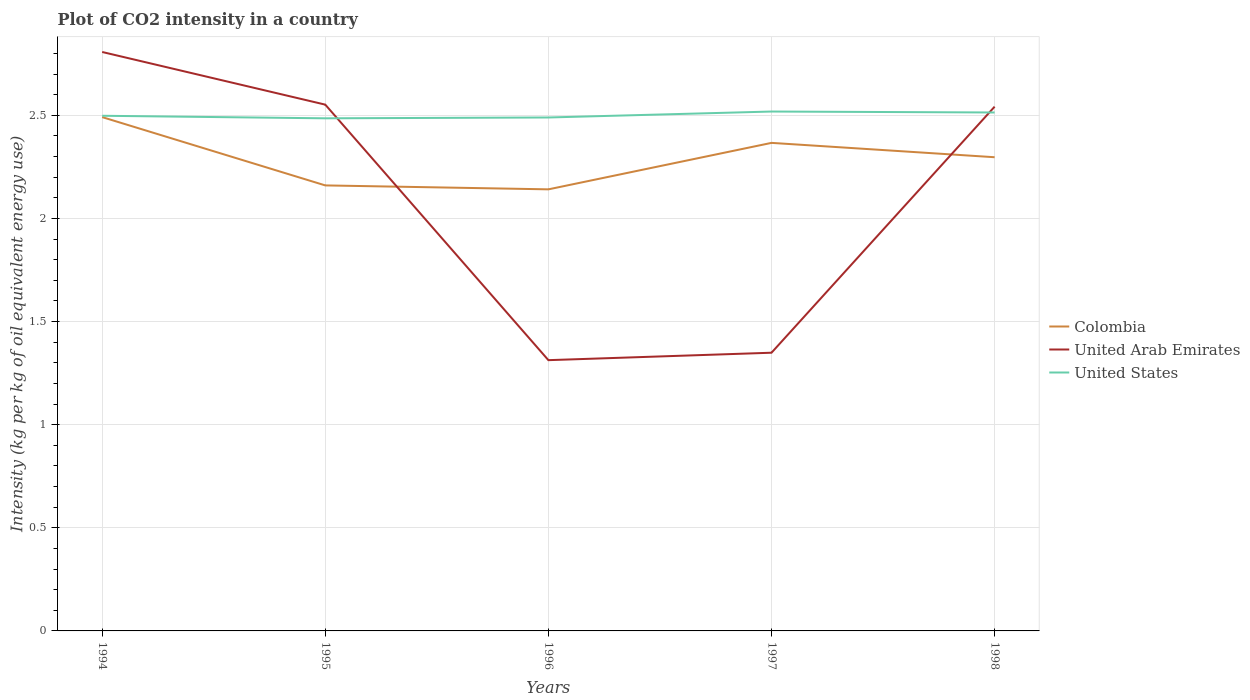Does the line corresponding to Colombia intersect with the line corresponding to United States?
Provide a short and direct response. No. Is the number of lines equal to the number of legend labels?
Ensure brevity in your answer.  Yes. Across all years, what is the maximum CO2 intensity in in United States?
Your answer should be compact. 2.49. What is the total CO2 intensity in in Colombia in the graph?
Your answer should be compact. 0.07. What is the difference between the highest and the second highest CO2 intensity in in Colombia?
Offer a very short reply. 0.35. How many lines are there?
Offer a terse response. 3. How many years are there in the graph?
Make the answer very short. 5. What is the difference between two consecutive major ticks on the Y-axis?
Offer a terse response. 0.5. Are the values on the major ticks of Y-axis written in scientific E-notation?
Provide a succinct answer. No. Does the graph contain any zero values?
Your answer should be compact. No. Where does the legend appear in the graph?
Offer a very short reply. Center right. How are the legend labels stacked?
Provide a succinct answer. Vertical. What is the title of the graph?
Offer a terse response. Plot of CO2 intensity in a country. What is the label or title of the X-axis?
Give a very brief answer. Years. What is the label or title of the Y-axis?
Make the answer very short. Intensity (kg per kg of oil equivalent energy use). What is the Intensity (kg per kg of oil equivalent energy use) of Colombia in 1994?
Your response must be concise. 2.49. What is the Intensity (kg per kg of oil equivalent energy use) in United Arab Emirates in 1994?
Keep it short and to the point. 2.81. What is the Intensity (kg per kg of oil equivalent energy use) of United States in 1994?
Ensure brevity in your answer.  2.5. What is the Intensity (kg per kg of oil equivalent energy use) of Colombia in 1995?
Provide a short and direct response. 2.16. What is the Intensity (kg per kg of oil equivalent energy use) of United Arab Emirates in 1995?
Offer a terse response. 2.55. What is the Intensity (kg per kg of oil equivalent energy use) in United States in 1995?
Ensure brevity in your answer.  2.49. What is the Intensity (kg per kg of oil equivalent energy use) in Colombia in 1996?
Provide a short and direct response. 2.14. What is the Intensity (kg per kg of oil equivalent energy use) in United Arab Emirates in 1996?
Your response must be concise. 1.31. What is the Intensity (kg per kg of oil equivalent energy use) in United States in 1996?
Your answer should be very brief. 2.49. What is the Intensity (kg per kg of oil equivalent energy use) in Colombia in 1997?
Ensure brevity in your answer.  2.37. What is the Intensity (kg per kg of oil equivalent energy use) of United Arab Emirates in 1997?
Your answer should be compact. 1.35. What is the Intensity (kg per kg of oil equivalent energy use) of United States in 1997?
Your answer should be very brief. 2.52. What is the Intensity (kg per kg of oil equivalent energy use) in Colombia in 1998?
Ensure brevity in your answer.  2.3. What is the Intensity (kg per kg of oil equivalent energy use) of United Arab Emirates in 1998?
Keep it short and to the point. 2.54. What is the Intensity (kg per kg of oil equivalent energy use) in United States in 1998?
Your answer should be very brief. 2.51. Across all years, what is the maximum Intensity (kg per kg of oil equivalent energy use) of Colombia?
Offer a very short reply. 2.49. Across all years, what is the maximum Intensity (kg per kg of oil equivalent energy use) in United Arab Emirates?
Your answer should be compact. 2.81. Across all years, what is the maximum Intensity (kg per kg of oil equivalent energy use) of United States?
Offer a terse response. 2.52. Across all years, what is the minimum Intensity (kg per kg of oil equivalent energy use) of Colombia?
Your response must be concise. 2.14. Across all years, what is the minimum Intensity (kg per kg of oil equivalent energy use) in United Arab Emirates?
Your answer should be very brief. 1.31. Across all years, what is the minimum Intensity (kg per kg of oil equivalent energy use) of United States?
Ensure brevity in your answer.  2.49. What is the total Intensity (kg per kg of oil equivalent energy use) of Colombia in the graph?
Your response must be concise. 11.46. What is the total Intensity (kg per kg of oil equivalent energy use) of United Arab Emirates in the graph?
Your answer should be very brief. 10.56. What is the total Intensity (kg per kg of oil equivalent energy use) in United States in the graph?
Your answer should be compact. 12.5. What is the difference between the Intensity (kg per kg of oil equivalent energy use) in Colombia in 1994 and that in 1995?
Your answer should be compact. 0.33. What is the difference between the Intensity (kg per kg of oil equivalent energy use) in United Arab Emirates in 1994 and that in 1995?
Offer a terse response. 0.26. What is the difference between the Intensity (kg per kg of oil equivalent energy use) in United States in 1994 and that in 1995?
Provide a short and direct response. 0.01. What is the difference between the Intensity (kg per kg of oil equivalent energy use) in Colombia in 1994 and that in 1996?
Ensure brevity in your answer.  0.35. What is the difference between the Intensity (kg per kg of oil equivalent energy use) of United Arab Emirates in 1994 and that in 1996?
Provide a short and direct response. 1.49. What is the difference between the Intensity (kg per kg of oil equivalent energy use) in United States in 1994 and that in 1996?
Give a very brief answer. 0.01. What is the difference between the Intensity (kg per kg of oil equivalent energy use) of Colombia in 1994 and that in 1997?
Offer a very short reply. 0.12. What is the difference between the Intensity (kg per kg of oil equivalent energy use) of United Arab Emirates in 1994 and that in 1997?
Make the answer very short. 1.46. What is the difference between the Intensity (kg per kg of oil equivalent energy use) in United States in 1994 and that in 1997?
Ensure brevity in your answer.  -0.02. What is the difference between the Intensity (kg per kg of oil equivalent energy use) in Colombia in 1994 and that in 1998?
Offer a very short reply. 0.19. What is the difference between the Intensity (kg per kg of oil equivalent energy use) of United Arab Emirates in 1994 and that in 1998?
Make the answer very short. 0.27. What is the difference between the Intensity (kg per kg of oil equivalent energy use) of United States in 1994 and that in 1998?
Provide a short and direct response. -0.02. What is the difference between the Intensity (kg per kg of oil equivalent energy use) in Colombia in 1995 and that in 1996?
Ensure brevity in your answer.  0.02. What is the difference between the Intensity (kg per kg of oil equivalent energy use) in United Arab Emirates in 1995 and that in 1996?
Keep it short and to the point. 1.24. What is the difference between the Intensity (kg per kg of oil equivalent energy use) of United States in 1995 and that in 1996?
Your answer should be very brief. -0. What is the difference between the Intensity (kg per kg of oil equivalent energy use) of Colombia in 1995 and that in 1997?
Offer a terse response. -0.21. What is the difference between the Intensity (kg per kg of oil equivalent energy use) of United Arab Emirates in 1995 and that in 1997?
Give a very brief answer. 1.2. What is the difference between the Intensity (kg per kg of oil equivalent energy use) of United States in 1995 and that in 1997?
Provide a short and direct response. -0.03. What is the difference between the Intensity (kg per kg of oil equivalent energy use) in Colombia in 1995 and that in 1998?
Provide a succinct answer. -0.14. What is the difference between the Intensity (kg per kg of oil equivalent energy use) in United Arab Emirates in 1995 and that in 1998?
Offer a very short reply. 0.01. What is the difference between the Intensity (kg per kg of oil equivalent energy use) in United States in 1995 and that in 1998?
Your response must be concise. -0.03. What is the difference between the Intensity (kg per kg of oil equivalent energy use) of Colombia in 1996 and that in 1997?
Keep it short and to the point. -0.23. What is the difference between the Intensity (kg per kg of oil equivalent energy use) in United Arab Emirates in 1996 and that in 1997?
Your response must be concise. -0.04. What is the difference between the Intensity (kg per kg of oil equivalent energy use) of United States in 1996 and that in 1997?
Provide a succinct answer. -0.03. What is the difference between the Intensity (kg per kg of oil equivalent energy use) in Colombia in 1996 and that in 1998?
Your answer should be compact. -0.16. What is the difference between the Intensity (kg per kg of oil equivalent energy use) in United Arab Emirates in 1996 and that in 1998?
Your answer should be compact. -1.23. What is the difference between the Intensity (kg per kg of oil equivalent energy use) of United States in 1996 and that in 1998?
Give a very brief answer. -0.02. What is the difference between the Intensity (kg per kg of oil equivalent energy use) of Colombia in 1997 and that in 1998?
Offer a terse response. 0.07. What is the difference between the Intensity (kg per kg of oil equivalent energy use) in United Arab Emirates in 1997 and that in 1998?
Ensure brevity in your answer.  -1.19. What is the difference between the Intensity (kg per kg of oil equivalent energy use) of United States in 1997 and that in 1998?
Provide a succinct answer. 0. What is the difference between the Intensity (kg per kg of oil equivalent energy use) of Colombia in 1994 and the Intensity (kg per kg of oil equivalent energy use) of United Arab Emirates in 1995?
Ensure brevity in your answer.  -0.06. What is the difference between the Intensity (kg per kg of oil equivalent energy use) in Colombia in 1994 and the Intensity (kg per kg of oil equivalent energy use) in United States in 1995?
Ensure brevity in your answer.  0.01. What is the difference between the Intensity (kg per kg of oil equivalent energy use) in United Arab Emirates in 1994 and the Intensity (kg per kg of oil equivalent energy use) in United States in 1995?
Offer a very short reply. 0.32. What is the difference between the Intensity (kg per kg of oil equivalent energy use) of Colombia in 1994 and the Intensity (kg per kg of oil equivalent energy use) of United Arab Emirates in 1996?
Keep it short and to the point. 1.18. What is the difference between the Intensity (kg per kg of oil equivalent energy use) in Colombia in 1994 and the Intensity (kg per kg of oil equivalent energy use) in United States in 1996?
Offer a very short reply. 0. What is the difference between the Intensity (kg per kg of oil equivalent energy use) in United Arab Emirates in 1994 and the Intensity (kg per kg of oil equivalent energy use) in United States in 1996?
Make the answer very short. 0.32. What is the difference between the Intensity (kg per kg of oil equivalent energy use) of Colombia in 1994 and the Intensity (kg per kg of oil equivalent energy use) of United Arab Emirates in 1997?
Ensure brevity in your answer.  1.14. What is the difference between the Intensity (kg per kg of oil equivalent energy use) of Colombia in 1994 and the Intensity (kg per kg of oil equivalent energy use) of United States in 1997?
Your answer should be very brief. -0.03. What is the difference between the Intensity (kg per kg of oil equivalent energy use) of United Arab Emirates in 1994 and the Intensity (kg per kg of oil equivalent energy use) of United States in 1997?
Offer a very short reply. 0.29. What is the difference between the Intensity (kg per kg of oil equivalent energy use) in Colombia in 1994 and the Intensity (kg per kg of oil equivalent energy use) in United Arab Emirates in 1998?
Provide a succinct answer. -0.05. What is the difference between the Intensity (kg per kg of oil equivalent energy use) of Colombia in 1994 and the Intensity (kg per kg of oil equivalent energy use) of United States in 1998?
Your response must be concise. -0.02. What is the difference between the Intensity (kg per kg of oil equivalent energy use) in United Arab Emirates in 1994 and the Intensity (kg per kg of oil equivalent energy use) in United States in 1998?
Keep it short and to the point. 0.29. What is the difference between the Intensity (kg per kg of oil equivalent energy use) in Colombia in 1995 and the Intensity (kg per kg of oil equivalent energy use) in United Arab Emirates in 1996?
Provide a short and direct response. 0.85. What is the difference between the Intensity (kg per kg of oil equivalent energy use) in Colombia in 1995 and the Intensity (kg per kg of oil equivalent energy use) in United States in 1996?
Offer a terse response. -0.33. What is the difference between the Intensity (kg per kg of oil equivalent energy use) in United Arab Emirates in 1995 and the Intensity (kg per kg of oil equivalent energy use) in United States in 1996?
Provide a succinct answer. 0.06. What is the difference between the Intensity (kg per kg of oil equivalent energy use) in Colombia in 1995 and the Intensity (kg per kg of oil equivalent energy use) in United Arab Emirates in 1997?
Offer a terse response. 0.81. What is the difference between the Intensity (kg per kg of oil equivalent energy use) in Colombia in 1995 and the Intensity (kg per kg of oil equivalent energy use) in United States in 1997?
Ensure brevity in your answer.  -0.36. What is the difference between the Intensity (kg per kg of oil equivalent energy use) of United Arab Emirates in 1995 and the Intensity (kg per kg of oil equivalent energy use) of United States in 1997?
Your response must be concise. 0.03. What is the difference between the Intensity (kg per kg of oil equivalent energy use) of Colombia in 1995 and the Intensity (kg per kg of oil equivalent energy use) of United Arab Emirates in 1998?
Keep it short and to the point. -0.38. What is the difference between the Intensity (kg per kg of oil equivalent energy use) in Colombia in 1995 and the Intensity (kg per kg of oil equivalent energy use) in United States in 1998?
Give a very brief answer. -0.35. What is the difference between the Intensity (kg per kg of oil equivalent energy use) in United Arab Emirates in 1995 and the Intensity (kg per kg of oil equivalent energy use) in United States in 1998?
Your response must be concise. 0.04. What is the difference between the Intensity (kg per kg of oil equivalent energy use) of Colombia in 1996 and the Intensity (kg per kg of oil equivalent energy use) of United Arab Emirates in 1997?
Offer a terse response. 0.79. What is the difference between the Intensity (kg per kg of oil equivalent energy use) in Colombia in 1996 and the Intensity (kg per kg of oil equivalent energy use) in United States in 1997?
Your answer should be compact. -0.38. What is the difference between the Intensity (kg per kg of oil equivalent energy use) in United Arab Emirates in 1996 and the Intensity (kg per kg of oil equivalent energy use) in United States in 1997?
Your response must be concise. -1.21. What is the difference between the Intensity (kg per kg of oil equivalent energy use) in Colombia in 1996 and the Intensity (kg per kg of oil equivalent energy use) in United Arab Emirates in 1998?
Make the answer very short. -0.4. What is the difference between the Intensity (kg per kg of oil equivalent energy use) in Colombia in 1996 and the Intensity (kg per kg of oil equivalent energy use) in United States in 1998?
Give a very brief answer. -0.37. What is the difference between the Intensity (kg per kg of oil equivalent energy use) of United Arab Emirates in 1996 and the Intensity (kg per kg of oil equivalent energy use) of United States in 1998?
Give a very brief answer. -1.2. What is the difference between the Intensity (kg per kg of oil equivalent energy use) of Colombia in 1997 and the Intensity (kg per kg of oil equivalent energy use) of United Arab Emirates in 1998?
Provide a succinct answer. -0.18. What is the difference between the Intensity (kg per kg of oil equivalent energy use) in Colombia in 1997 and the Intensity (kg per kg of oil equivalent energy use) in United States in 1998?
Provide a short and direct response. -0.15. What is the difference between the Intensity (kg per kg of oil equivalent energy use) of United Arab Emirates in 1997 and the Intensity (kg per kg of oil equivalent energy use) of United States in 1998?
Your answer should be very brief. -1.16. What is the average Intensity (kg per kg of oil equivalent energy use) of Colombia per year?
Offer a terse response. 2.29. What is the average Intensity (kg per kg of oil equivalent energy use) of United Arab Emirates per year?
Provide a succinct answer. 2.11. What is the average Intensity (kg per kg of oil equivalent energy use) in United States per year?
Provide a succinct answer. 2.5. In the year 1994, what is the difference between the Intensity (kg per kg of oil equivalent energy use) in Colombia and Intensity (kg per kg of oil equivalent energy use) in United Arab Emirates?
Your response must be concise. -0.32. In the year 1994, what is the difference between the Intensity (kg per kg of oil equivalent energy use) of Colombia and Intensity (kg per kg of oil equivalent energy use) of United States?
Make the answer very short. -0.01. In the year 1994, what is the difference between the Intensity (kg per kg of oil equivalent energy use) of United Arab Emirates and Intensity (kg per kg of oil equivalent energy use) of United States?
Offer a terse response. 0.31. In the year 1995, what is the difference between the Intensity (kg per kg of oil equivalent energy use) of Colombia and Intensity (kg per kg of oil equivalent energy use) of United Arab Emirates?
Give a very brief answer. -0.39. In the year 1995, what is the difference between the Intensity (kg per kg of oil equivalent energy use) in Colombia and Intensity (kg per kg of oil equivalent energy use) in United States?
Your answer should be very brief. -0.33. In the year 1995, what is the difference between the Intensity (kg per kg of oil equivalent energy use) of United Arab Emirates and Intensity (kg per kg of oil equivalent energy use) of United States?
Keep it short and to the point. 0.07. In the year 1996, what is the difference between the Intensity (kg per kg of oil equivalent energy use) of Colombia and Intensity (kg per kg of oil equivalent energy use) of United Arab Emirates?
Your response must be concise. 0.83. In the year 1996, what is the difference between the Intensity (kg per kg of oil equivalent energy use) in Colombia and Intensity (kg per kg of oil equivalent energy use) in United States?
Provide a succinct answer. -0.35. In the year 1996, what is the difference between the Intensity (kg per kg of oil equivalent energy use) in United Arab Emirates and Intensity (kg per kg of oil equivalent energy use) in United States?
Ensure brevity in your answer.  -1.18. In the year 1997, what is the difference between the Intensity (kg per kg of oil equivalent energy use) of Colombia and Intensity (kg per kg of oil equivalent energy use) of United Arab Emirates?
Keep it short and to the point. 1.02. In the year 1997, what is the difference between the Intensity (kg per kg of oil equivalent energy use) in Colombia and Intensity (kg per kg of oil equivalent energy use) in United States?
Provide a short and direct response. -0.15. In the year 1997, what is the difference between the Intensity (kg per kg of oil equivalent energy use) in United Arab Emirates and Intensity (kg per kg of oil equivalent energy use) in United States?
Ensure brevity in your answer.  -1.17. In the year 1998, what is the difference between the Intensity (kg per kg of oil equivalent energy use) in Colombia and Intensity (kg per kg of oil equivalent energy use) in United Arab Emirates?
Keep it short and to the point. -0.25. In the year 1998, what is the difference between the Intensity (kg per kg of oil equivalent energy use) of Colombia and Intensity (kg per kg of oil equivalent energy use) of United States?
Give a very brief answer. -0.22. In the year 1998, what is the difference between the Intensity (kg per kg of oil equivalent energy use) in United Arab Emirates and Intensity (kg per kg of oil equivalent energy use) in United States?
Your answer should be compact. 0.03. What is the ratio of the Intensity (kg per kg of oil equivalent energy use) of Colombia in 1994 to that in 1995?
Keep it short and to the point. 1.15. What is the ratio of the Intensity (kg per kg of oil equivalent energy use) in United Arab Emirates in 1994 to that in 1995?
Offer a terse response. 1.1. What is the ratio of the Intensity (kg per kg of oil equivalent energy use) of United States in 1994 to that in 1995?
Offer a very short reply. 1. What is the ratio of the Intensity (kg per kg of oil equivalent energy use) of Colombia in 1994 to that in 1996?
Give a very brief answer. 1.16. What is the ratio of the Intensity (kg per kg of oil equivalent energy use) of United Arab Emirates in 1994 to that in 1996?
Ensure brevity in your answer.  2.14. What is the ratio of the Intensity (kg per kg of oil equivalent energy use) of Colombia in 1994 to that in 1997?
Provide a short and direct response. 1.05. What is the ratio of the Intensity (kg per kg of oil equivalent energy use) of United Arab Emirates in 1994 to that in 1997?
Give a very brief answer. 2.08. What is the ratio of the Intensity (kg per kg of oil equivalent energy use) in United States in 1994 to that in 1997?
Offer a terse response. 0.99. What is the ratio of the Intensity (kg per kg of oil equivalent energy use) in Colombia in 1994 to that in 1998?
Offer a terse response. 1.08. What is the ratio of the Intensity (kg per kg of oil equivalent energy use) of United Arab Emirates in 1994 to that in 1998?
Your answer should be very brief. 1.1. What is the ratio of the Intensity (kg per kg of oil equivalent energy use) in United States in 1994 to that in 1998?
Offer a terse response. 0.99. What is the ratio of the Intensity (kg per kg of oil equivalent energy use) in Colombia in 1995 to that in 1996?
Keep it short and to the point. 1.01. What is the ratio of the Intensity (kg per kg of oil equivalent energy use) in United Arab Emirates in 1995 to that in 1996?
Your response must be concise. 1.94. What is the ratio of the Intensity (kg per kg of oil equivalent energy use) in United States in 1995 to that in 1996?
Provide a short and direct response. 1. What is the ratio of the Intensity (kg per kg of oil equivalent energy use) in Colombia in 1995 to that in 1997?
Your answer should be compact. 0.91. What is the ratio of the Intensity (kg per kg of oil equivalent energy use) in United Arab Emirates in 1995 to that in 1997?
Your answer should be compact. 1.89. What is the ratio of the Intensity (kg per kg of oil equivalent energy use) in United States in 1995 to that in 1997?
Your response must be concise. 0.99. What is the ratio of the Intensity (kg per kg of oil equivalent energy use) of Colombia in 1995 to that in 1998?
Give a very brief answer. 0.94. What is the ratio of the Intensity (kg per kg of oil equivalent energy use) in United Arab Emirates in 1995 to that in 1998?
Ensure brevity in your answer.  1. What is the ratio of the Intensity (kg per kg of oil equivalent energy use) of Colombia in 1996 to that in 1997?
Your answer should be compact. 0.9. What is the ratio of the Intensity (kg per kg of oil equivalent energy use) in United Arab Emirates in 1996 to that in 1997?
Give a very brief answer. 0.97. What is the ratio of the Intensity (kg per kg of oil equivalent energy use) in United States in 1996 to that in 1997?
Provide a succinct answer. 0.99. What is the ratio of the Intensity (kg per kg of oil equivalent energy use) in Colombia in 1996 to that in 1998?
Offer a very short reply. 0.93. What is the ratio of the Intensity (kg per kg of oil equivalent energy use) of United Arab Emirates in 1996 to that in 1998?
Give a very brief answer. 0.52. What is the ratio of the Intensity (kg per kg of oil equivalent energy use) of United States in 1996 to that in 1998?
Make the answer very short. 0.99. What is the ratio of the Intensity (kg per kg of oil equivalent energy use) of Colombia in 1997 to that in 1998?
Give a very brief answer. 1.03. What is the ratio of the Intensity (kg per kg of oil equivalent energy use) of United Arab Emirates in 1997 to that in 1998?
Make the answer very short. 0.53. What is the ratio of the Intensity (kg per kg of oil equivalent energy use) of United States in 1997 to that in 1998?
Your answer should be compact. 1. What is the difference between the highest and the second highest Intensity (kg per kg of oil equivalent energy use) of Colombia?
Ensure brevity in your answer.  0.12. What is the difference between the highest and the second highest Intensity (kg per kg of oil equivalent energy use) in United Arab Emirates?
Give a very brief answer. 0.26. What is the difference between the highest and the second highest Intensity (kg per kg of oil equivalent energy use) of United States?
Your answer should be compact. 0. What is the difference between the highest and the lowest Intensity (kg per kg of oil equivalent energy use) of Colombia?
Provide a short and direct response. 0.35. What is the difference between the highest and the lowest Intensity (kg per kg of oil equivalent energy use) in United Arab Emirates?
Keep it short and to the point. 1.49. What is the difference between the highest and the lowest Intensity (kg per kg of oil equivalent energy use) of United States?
Your answer should be compact. 0.03. 